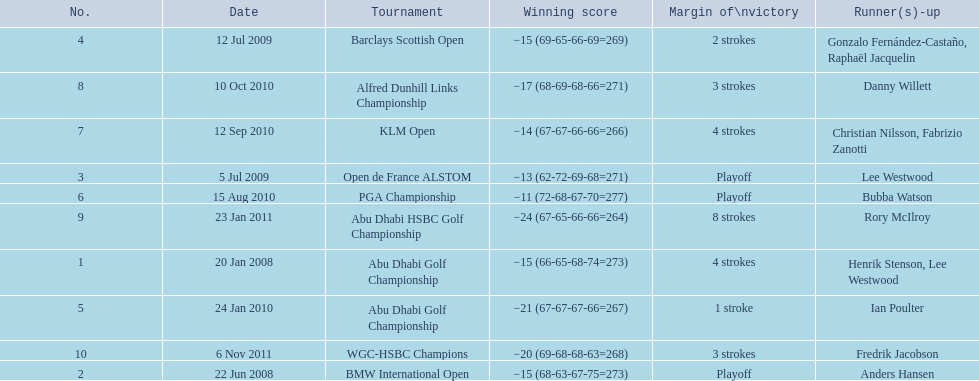How many strokes were in the klm open by martin kaymer? 4 strokes. How many strokes were in the abu dhabi golf championship? 4 strokes. How many more strokes were there in the klm than the barclays open? 2 strokes. 